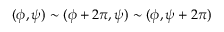<formula> <loc_0><loc_0><loc_500><loc_500>( \phi , \psi ) \sim ( \phi + 2 \pi , \psi ) \sim ( \phi , \psi + 2 \pi ) \,</formula> 